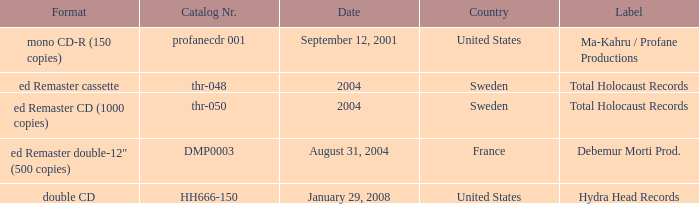Write the full table. {'header': ['Format', 'Catalog Nr.', 'Date', 'Country', 'Label'], 'rows': [['mono CD-R (150 copies)', 'profanecdr 001', 'September 12, 2001', 'United States', 'Ma-Kahru / Profane Productions'], ['ed Remaster cassette', 'thr-048', '2004', 'Sweden', 'Total Holocaust Records'], ['ed Remaster CD (1000 copies)', 'thr-050', '2004', 'Sweden', 'Total Holocaust Records'], ['ed Remaster double-12" (500 copies)', 'DMP0003', 'August 31, 2004', 'France', 'Debemur Morti Prod.'], ['double CD', 'HH666-150', 'January 29, 2008', 'United States', 'Hydra Head Records']]} What country is the Debemur Morti prod. label from? France. 